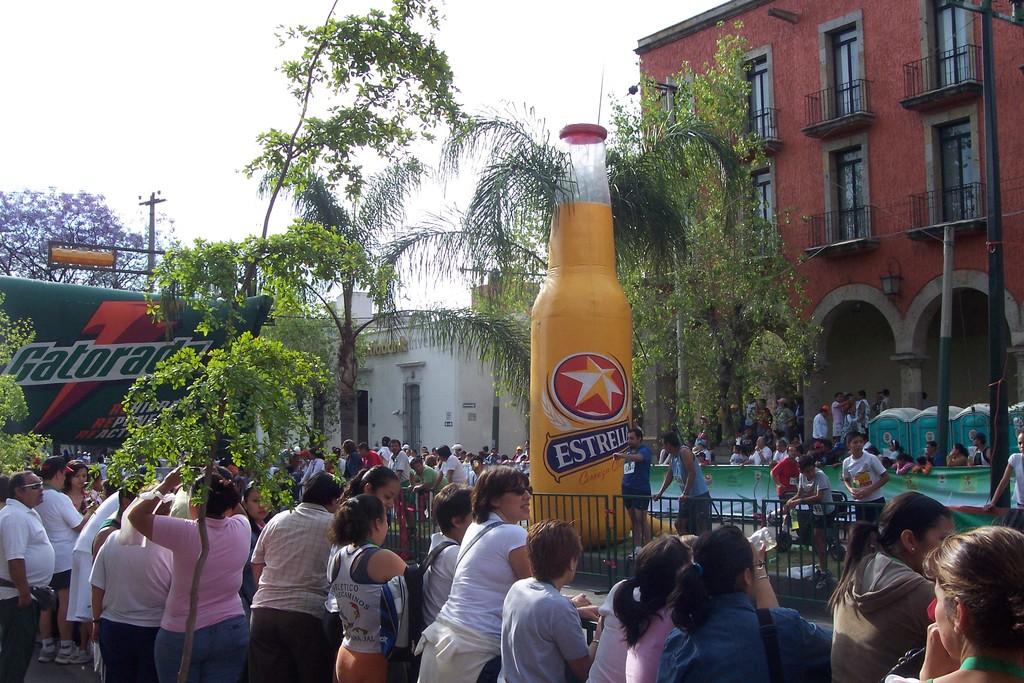What green sports drink is in the background?
Give a very brief answer. Gatorade. What drink is in the foreground?
Ensure brevity in your answer.  Estrella. 